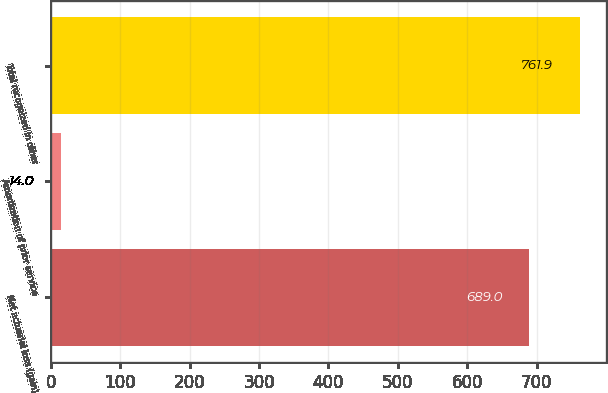<chart> <loc_0><loc_0><loc_500><loc_500><bar_chart><fcel>Net actuarial loss (gain)<fcel>Amortization of prior service<fcel>Total recognized in other<nl><fcel>689<fcel>14<fcel>761.9<nl></chart> 